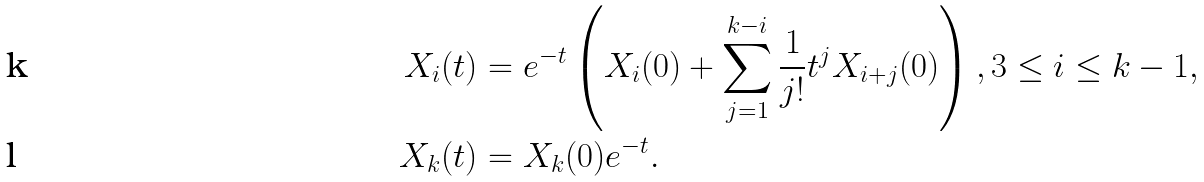Convert formula to latex. <formula><loc_0><loc_0><loc_500><loc_500>X _ { i } ( t ) & = e ^ { - t } \left ( X _ { i } ( 0 ) + \sum _ { j = 1 } ^ { k - i } \frac { 1 } { j ! } t ^ { j } X _ { i + j } ( 0 ) \right ) , 3 \leq i \leq k - 1 , \\ X _ { k } ( t ) & = X _ { k } ( 0 ) e ^ { - t } .</formula> 